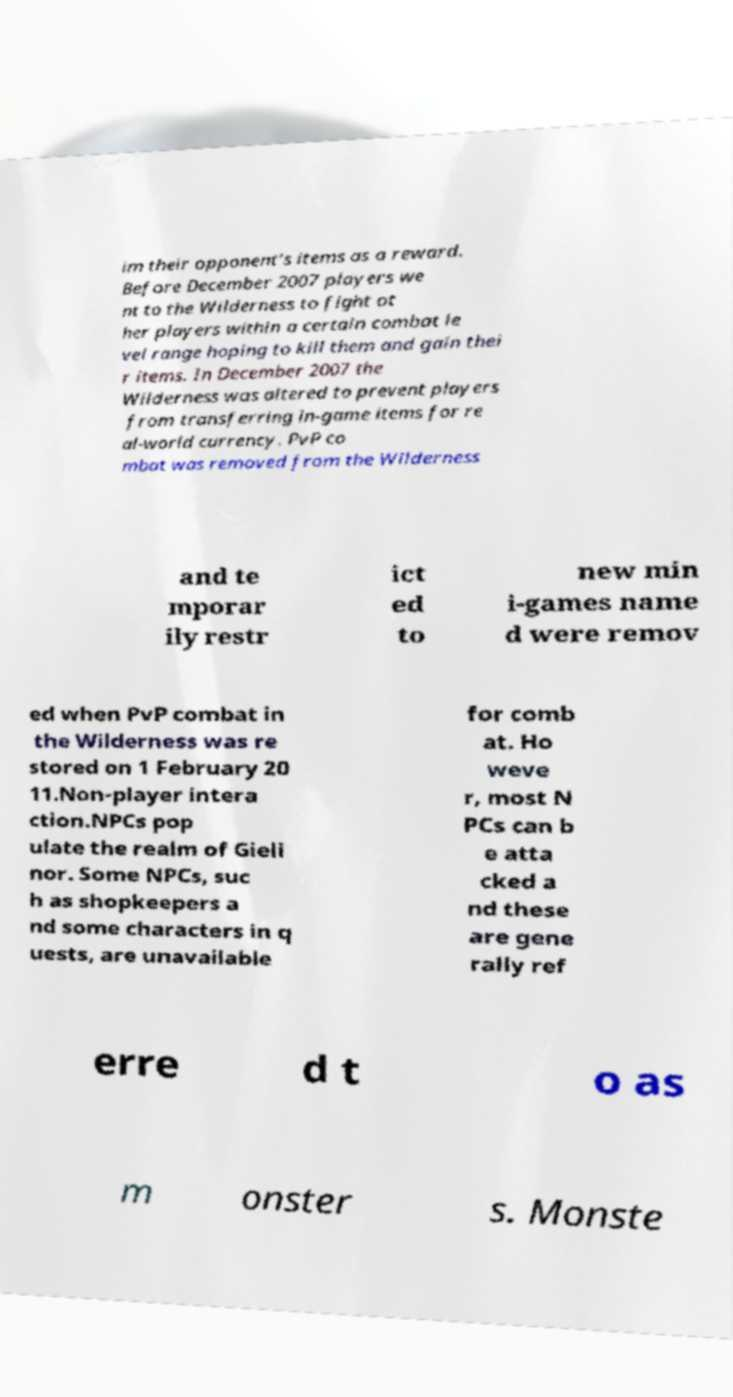I need the written content from this picture converted into text. Can you do that? im their opponent's items as a reward. Before December 2007 players we nt to the Wilderness to fight ot her players within a certain combat le vel range hoping to kill them and gain thei r items. In December 2007 the Wilderness was altered to prevent players from transferring in-game items for re al-world currency. PvP co mbat was removed from the Wilderness and te mporar ily restr ict ed to new min i-games name d were remov ed when PvP combat in the Wilderness was re stored on 1 February 20 11.Non-player intera ction.NPCs pop ulate the realm of Gieli nor. Some NPCs, suc h as shopkeepers a nd some characters in q uests, are unavailable for comb at. Ho weve r, most N PCs can b e atta cked a nd these are gene rally ref erre d t o as m onster s. Monste 